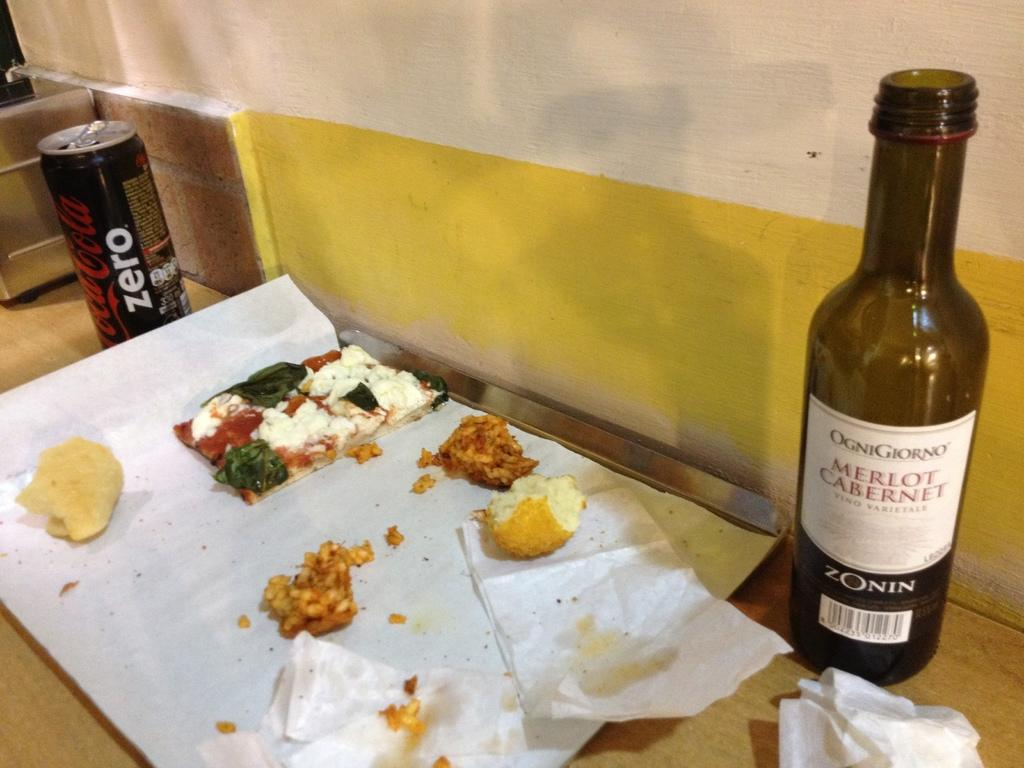Provide a one-sentence caption for the provided image. a wine bottle that says merlot caberet on it. 